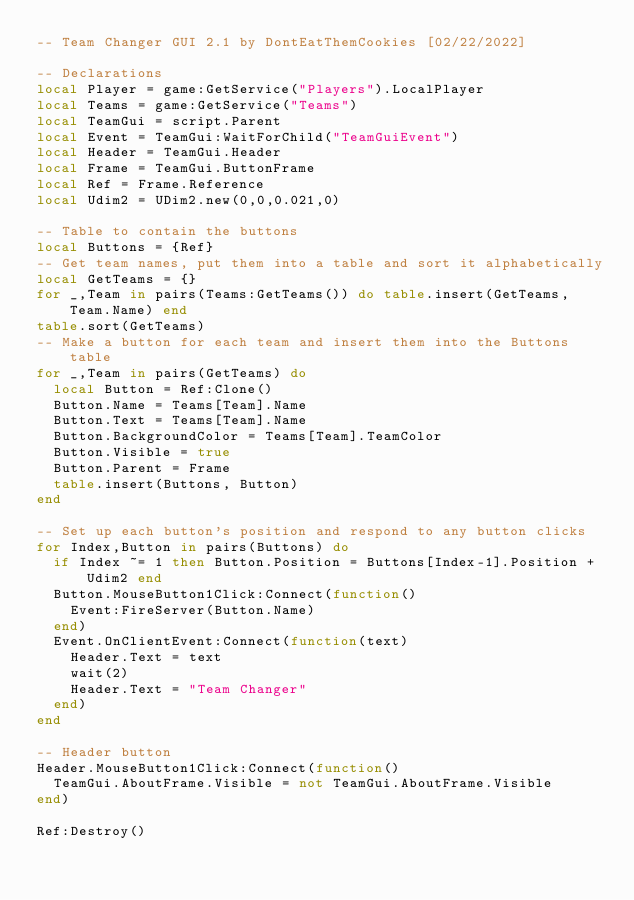Convert code to text. <code><loc_0><loc_0><loc_500><loc_500><_Lua_>-- Team Changer GUI 2.1 by DontEatThemCookies [02/22/2022]

-- Declarations
local Player = game:GetService("Players").LocalPlayer
local Teams = game:GetService("Teams")
local TeamGui = script.Parent
local Event = TeamGui:WaitForChild("TeamGuiEvent")
local Header = TeamGui.Header
local Frame = TeamGui.ButtonFrame
local Ref = Frame.Reference
local Udim2 = UDim2.new(0,0,0.021,0)

-- Table to contain the buttons
local Buttons = {Ref}
-- Get team names, put them into a table and sort it alphabetically
local GetTeams = {}
for _,Team in pairs(Teams:GetTeams()) do table.insert(GetTeams, Team.Name) end
table.sort(GetTeams)
-- Make a button for each team and insert them into the Buttons table
for _,Team in pairs(GetTeams) do
	local Button = Ref:Clone()
	Button.Name = Teams[Team].Name
	Button.Text = Teams[Team].Name
	Button.BackgroundColor = Teams[Team].TeamColor
	Button.Visible = true
	Button.Parent = Frame
	table.insert(Buttons, Button)
end

-- Set up each button's position and respond to any button clicks
for Index,Button in pairs(Buttons) do
	if Index ~= 1 then Button.Position = Buttons[Index-1].Position + Udim2 end
	Button.MouseButton1Click:Connect(function()
		Event:FireServer(Button.Name)
	end)
	Event.OnClientEvent:Connect(function(text)
		Header.Text = text
		wait(2)
		Header.Text = "Team Changer"
	end)
end

-- Header button
Header.MouseButton1Click:Connect(function()
	TeamGui.AboutFrame.Visible = not TeamGui.AboutFrame.Visible
end)

Ref:Destroy()
</code> 